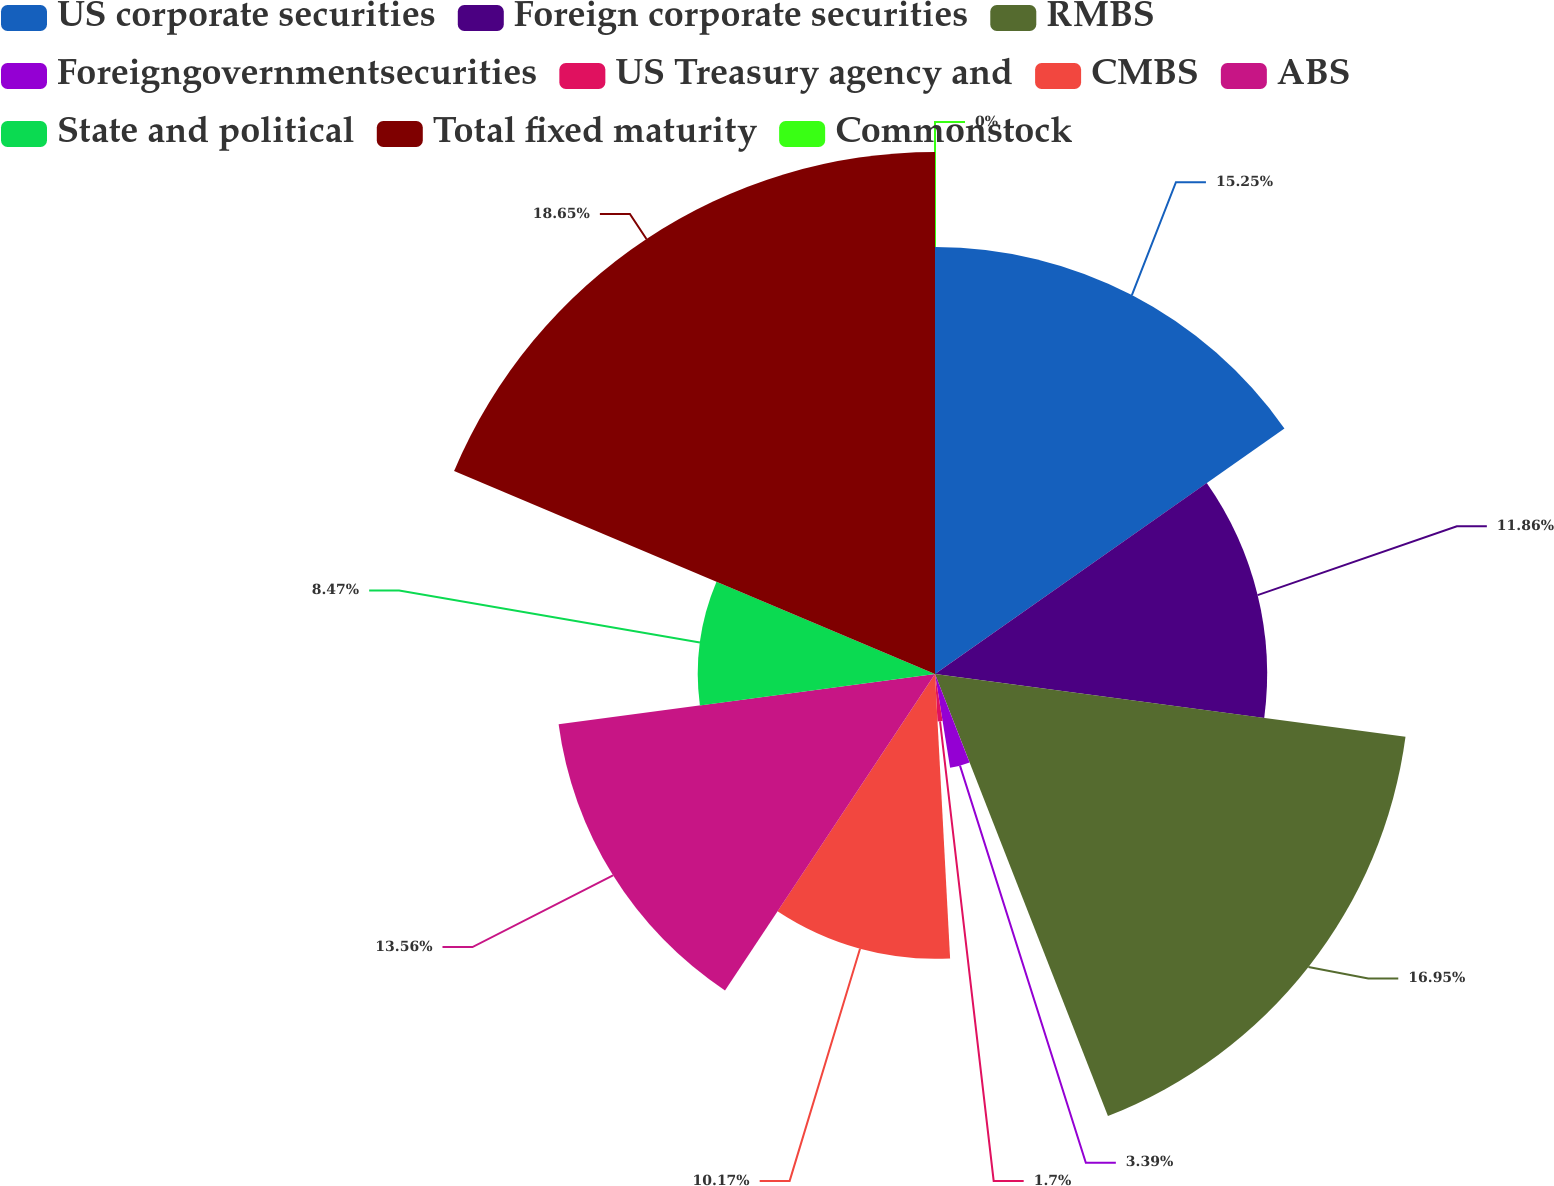Convert chart. <chart><loc_0><loc_0><loc_500><loc_500><pie_chart><fcel>US corporate securities<fcel>Foreign corporate securities<fcel>RMBS<fcel>Foreigngovernmentsecurities<fcel>US Treasury agency and<fcel>CMBS<fcel>ABS<fcel>State and political<fcel>Total fixed maturity<fcel>Commonstock<nl><fcel>15.25%<fcel>11.86%<fcel>16.95%<fcel>3.39%<fcel>1.7%<fcel>10.17%<fcel>13.56%<fcel>8.47%<fcel>18.64%<fcel>0.0%<nl></chart> 